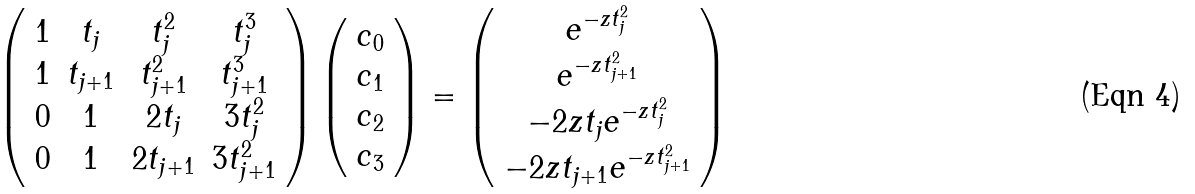<formula> <loc_0><loc_0><loc_500><loc_500>\left ( \begin{array} { c c c c } 1 & t _ { j } & t _ { j } ^ { 2 } & t _ { j } ^ { 3 } \\ 1 & t _ { j + 1 } & t _ { j + 1 } ^ { 2 } & t _ { j + 1 } ^ { 3 } \\ 0 & 1 & 2 t _ { j } & 3 t _ { j } ^ { 2 } \\ 0 & 1 & 2 t _ { j + 1 } & 3 t _ { j + 1 } ^ { 2 } \\ \end{array} \right ) \left ( \begin{array} { c } c _ { 0 } \\ c _ { 1 } \\ c _ { 2 } \\ c _ { 3 } \\ \end{array} \right ) = \left ( \begin{array} { c } e ^ { - z t _ { j } ^ { 2 } } \\ e ^ { - z t _ { j + 1 } ^ { 2 } } \\ - 2 z t _ { j } e ^ { - z t _ { j } ^ { 2 } } \\ - 2 z t _ { j + 1 } e ^ { - z t _ { j + 1 } ^ { 2 } } \\ \end{array} \right )</formula> 